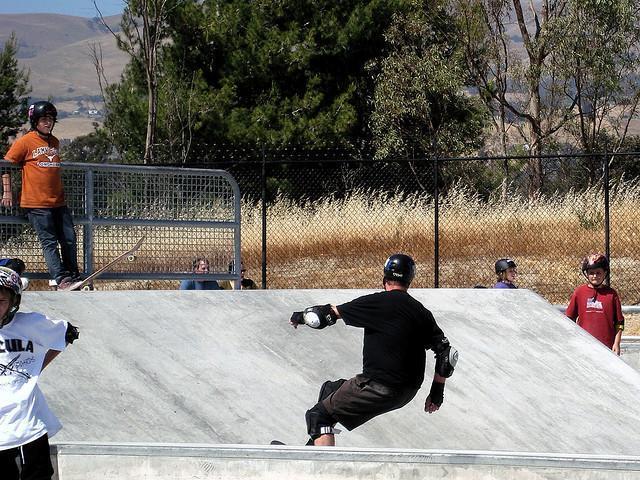How many people are wearing red?
Give a very brief answer. 1. How many people are visible?
Give a very brief answer. 4. 